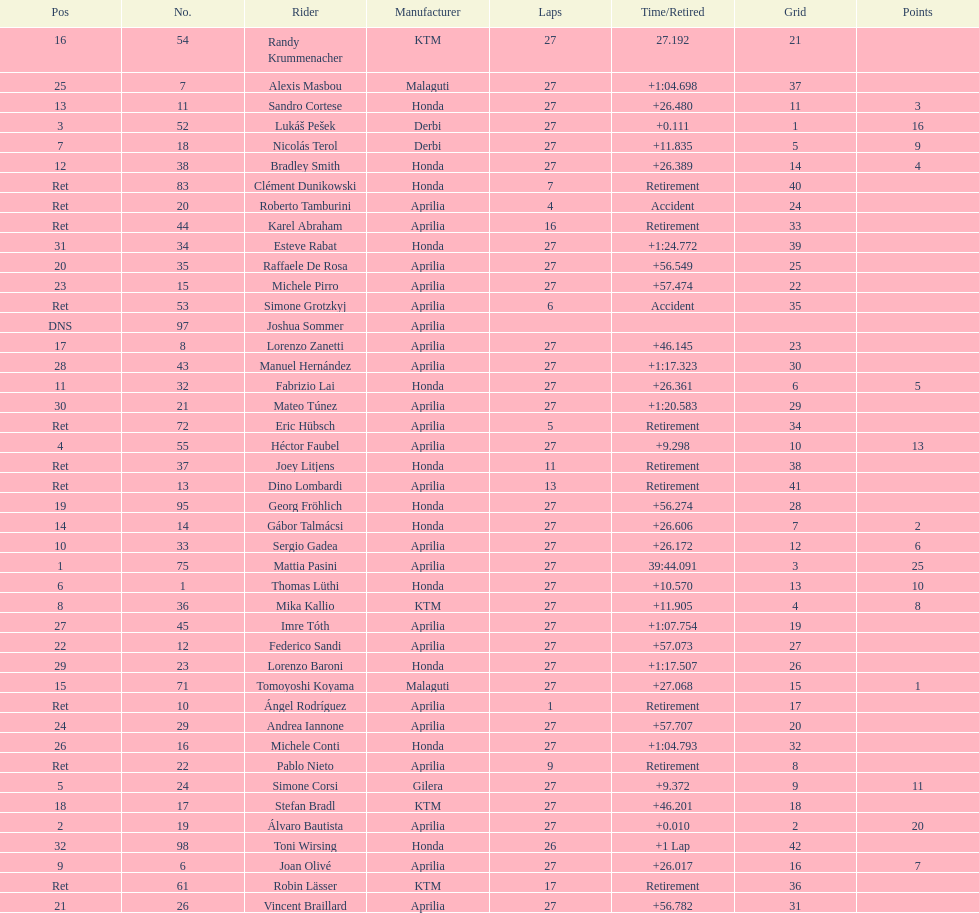How many racers did not use an aprilia or a honda? 9. 